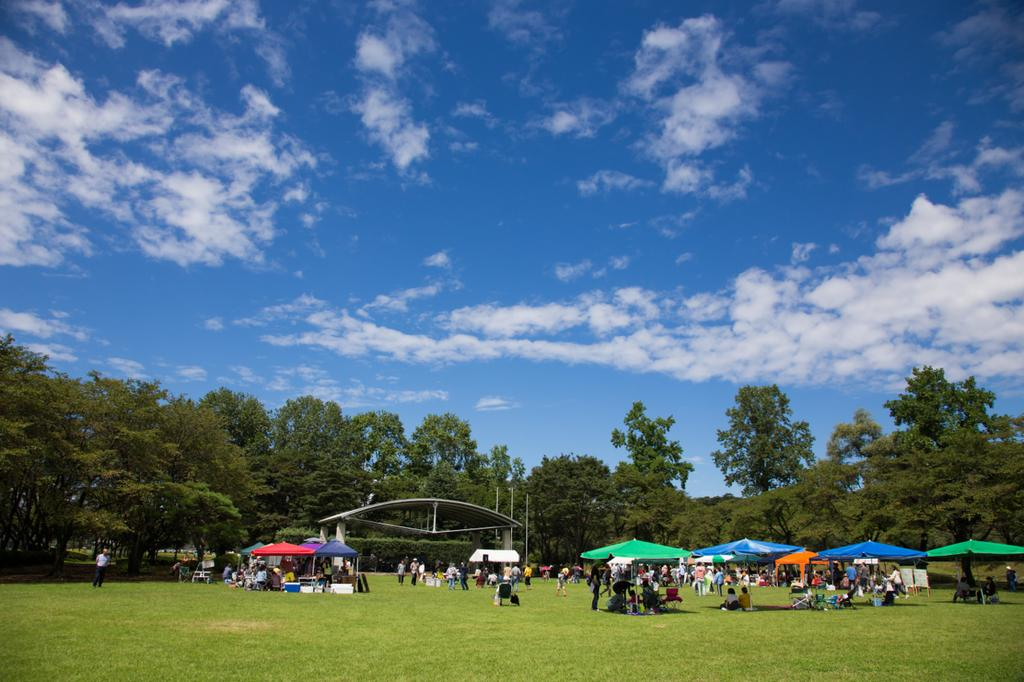What structures are located at the bottom of the image? There are tents at the bottom of the image. What else can be seen in the image besides the tents? There are people standing in the image. What type of natural environment is visible in the background of the image? There are trees in the background of the image. What is visible in the sky in the background of the image? The sky is visible in the background of the image. Can you see a chess game being played in the image? There is no chess game visible in the image. Is there a boy sitting on the grass in the image? The provided facts do not mention a boy or any grass in the image, so we cannot confirm or deny the presence of a boy. 